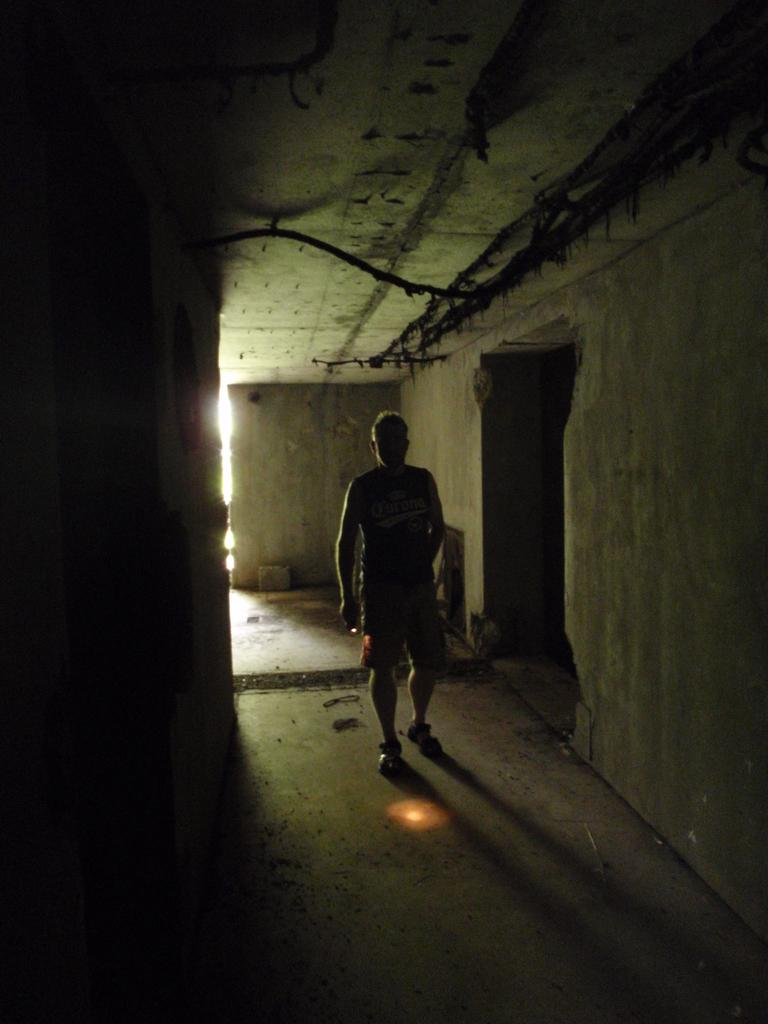Who is present in the image? There is a man in the image. What is the man doing in the image? The man is walking. Can you describe the walls in the image? The walls in the image are not completely furnished with cement. What type of science experiment is the man conducting in the image? There is no science experiment or any indication of scientific activity in the image. 